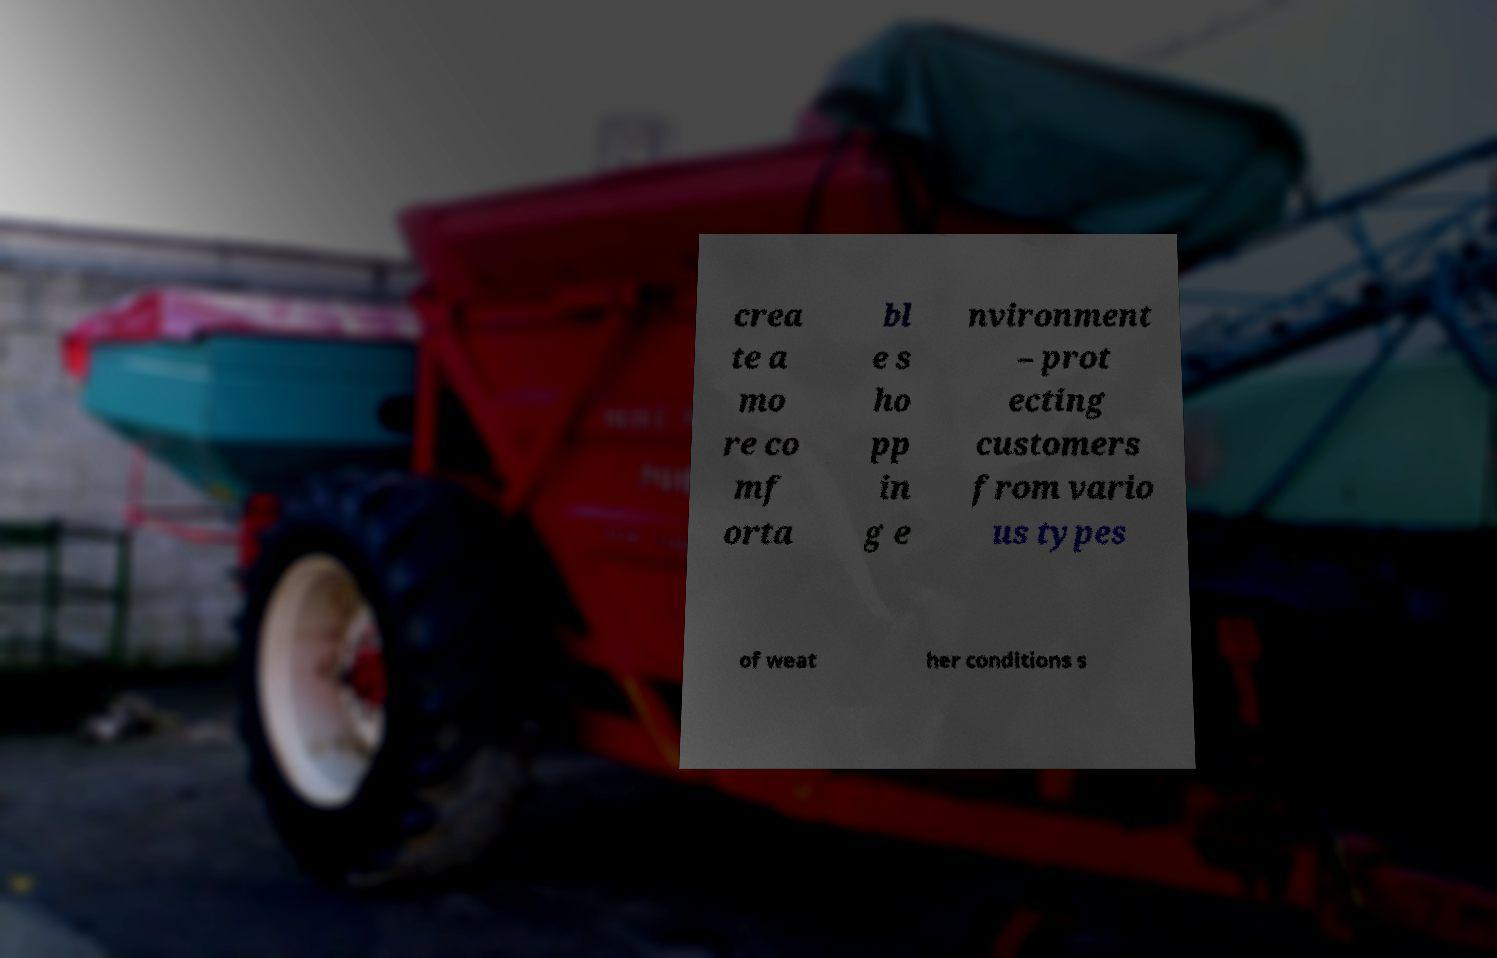Could you assist in decoding the text presented in this image and type it out clearly? crea te a mo re co mf orta bl e s ho pp in g e nvironment – prot ecting customers from vario us types of weat her conditions s 